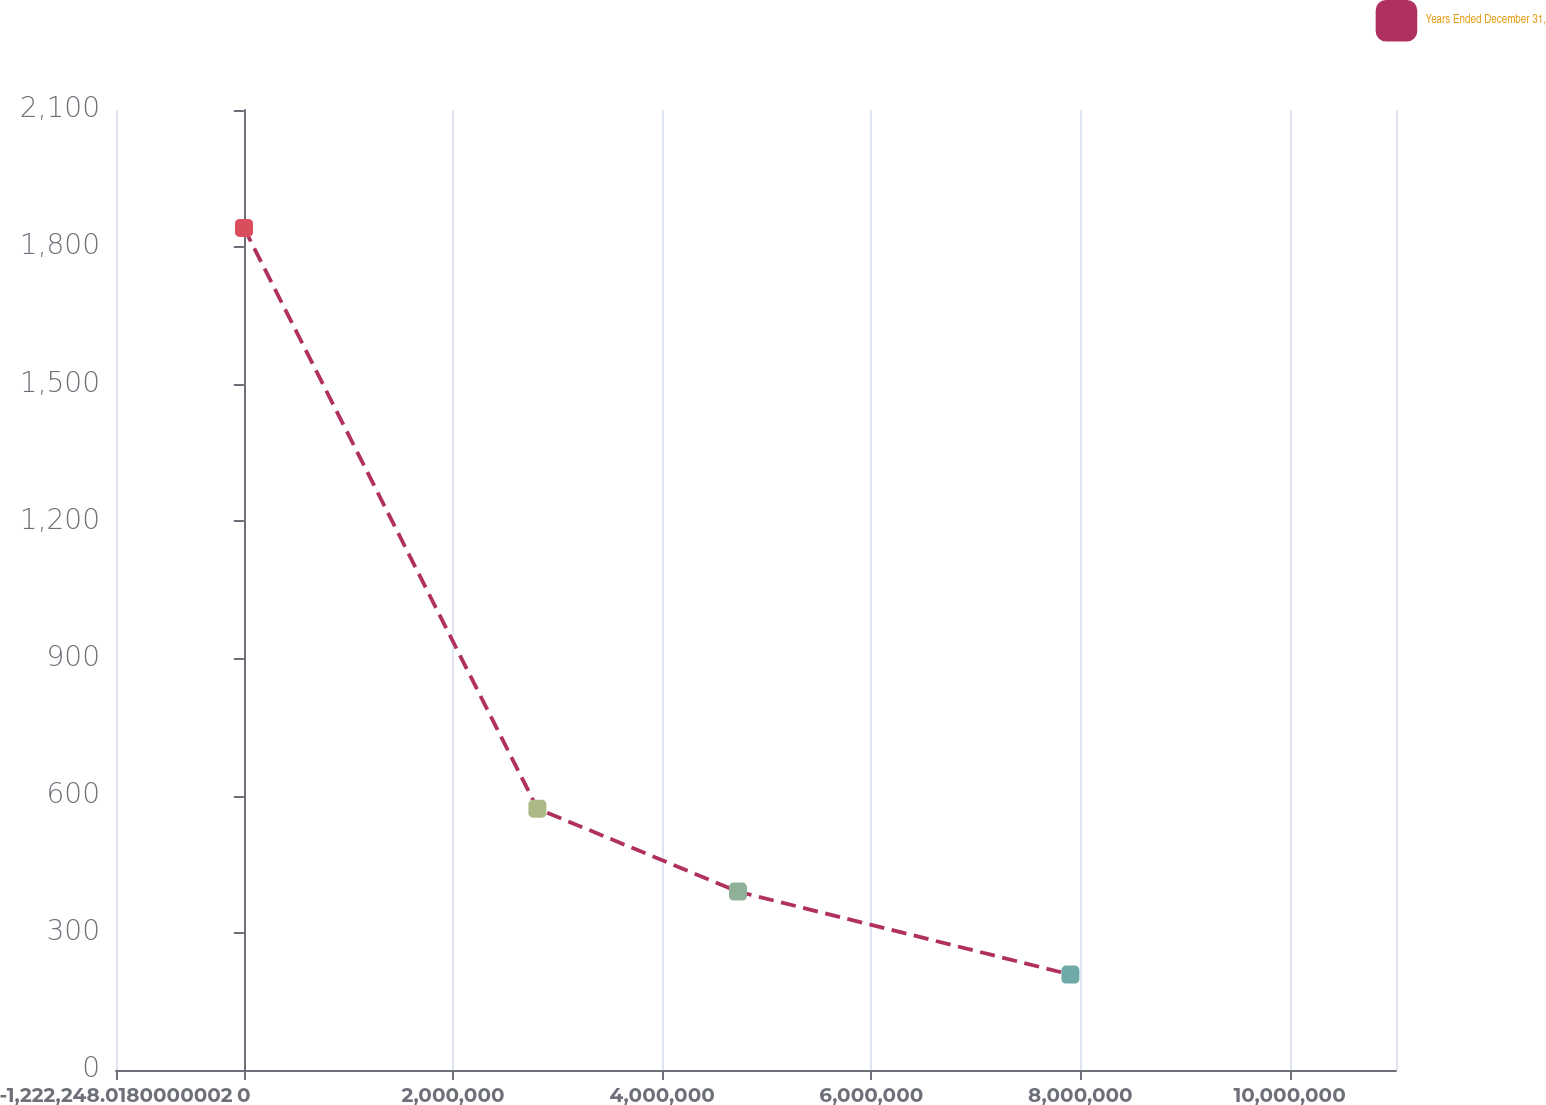Convert chart to OTSL. <chart><loc_0><loc_0><loc_500><loc_500><line_chart><ecel><fcel>Years Ended December 31,<nl><fcel>1758.15<fcel>1842<nl><fcel>2.80748e+06<fcel>571.72<nl><fcel>4.72516e+06<fcel>390.25<nl><fcel>7.90435e+06<fcel>208.78<nl><fcel>1.22418e+07<fcel>27.31<nl></chart> 